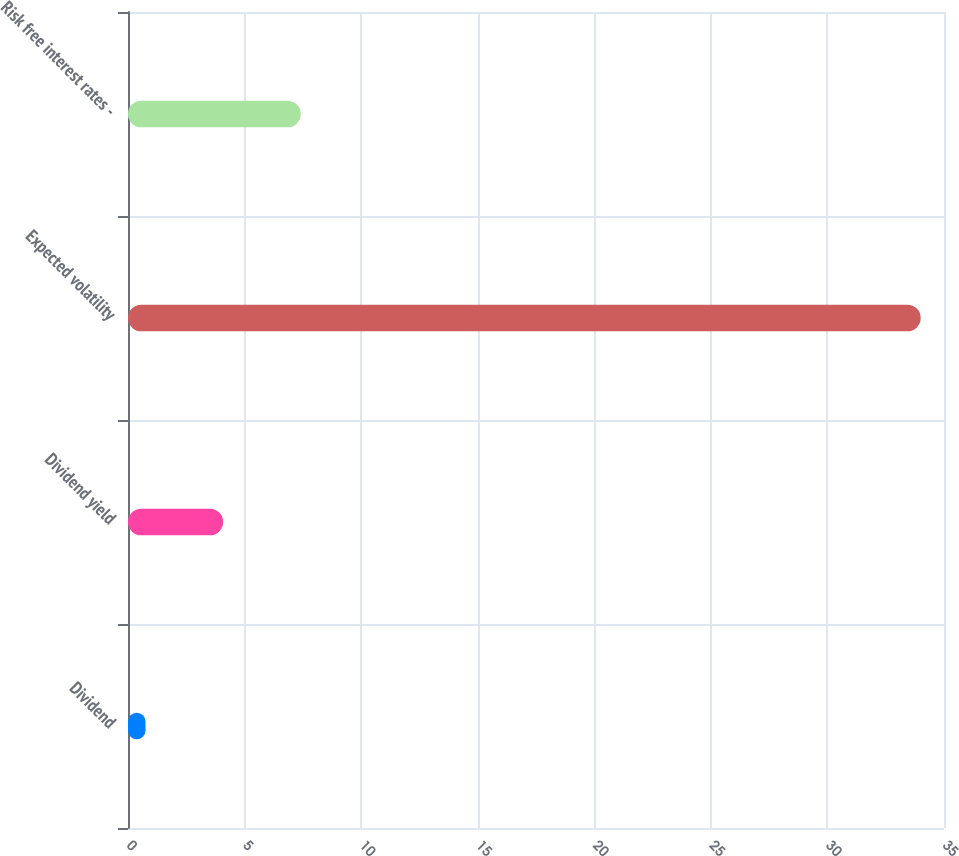Convert chart to OTSL. <chart><loc_0><loc_0><loc_500><loc_500><bar_chart><fcel>Dividend<fcel>Dividend yield<fcel>Expected volatility<fcel>Risk free interest rates -<nl><fcel>0.75<fcel>4.08<fcel>34<fcel>7.41<nl></chart> 